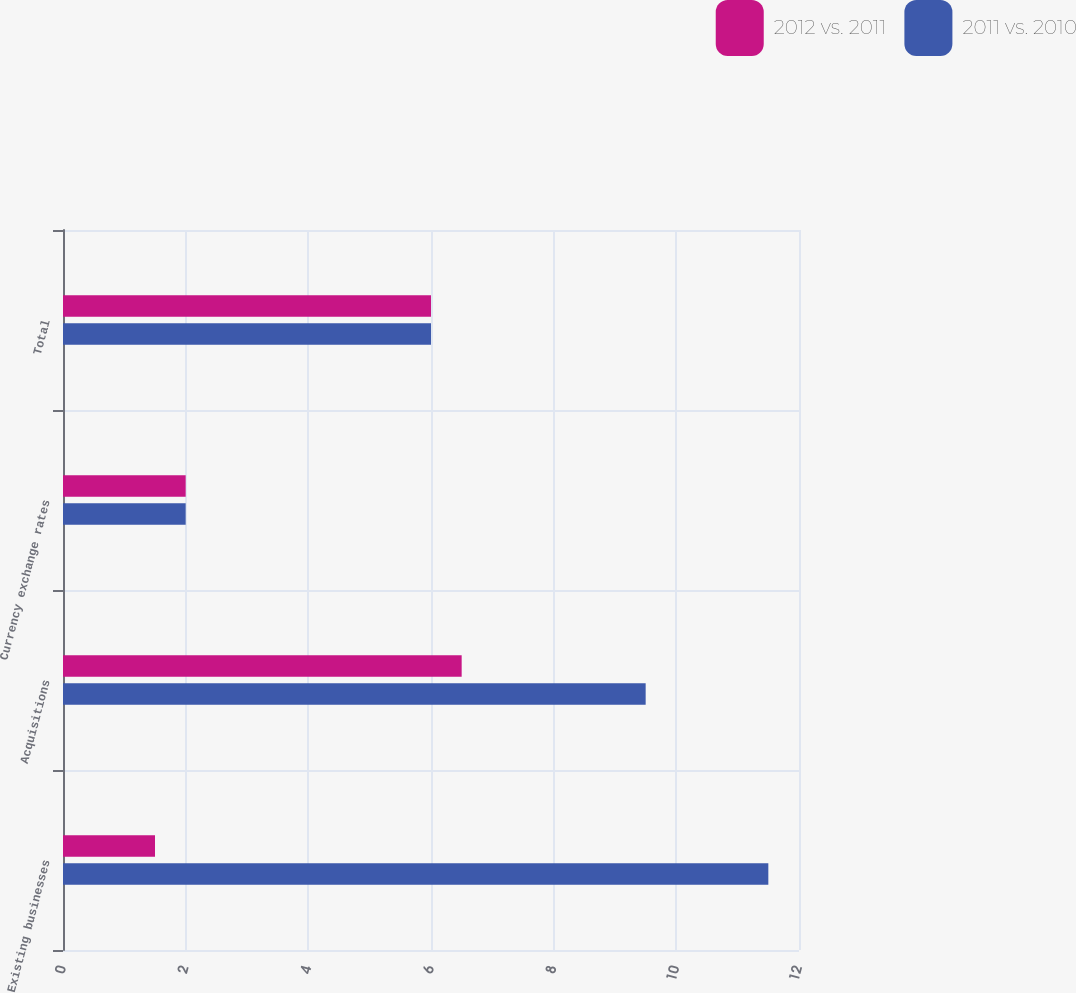Convert chart to OTSL. <chart><loc_0><loc_0><loc_500><loc_500><stacked_bar_chart><ecel><fcel>Existing businesses<fcel>Acquisitions<fcel>Currency exchange rates<fcel>Total<nl><fcel>2012 vs. 2011<fcel>1.5<fcel>6.5<fcel>2<fcel>6<nl><fcel>2011 vs. 2010<fcel>11.5<fcel>9.5<fcel>2<fcel>6<nl></chart> 